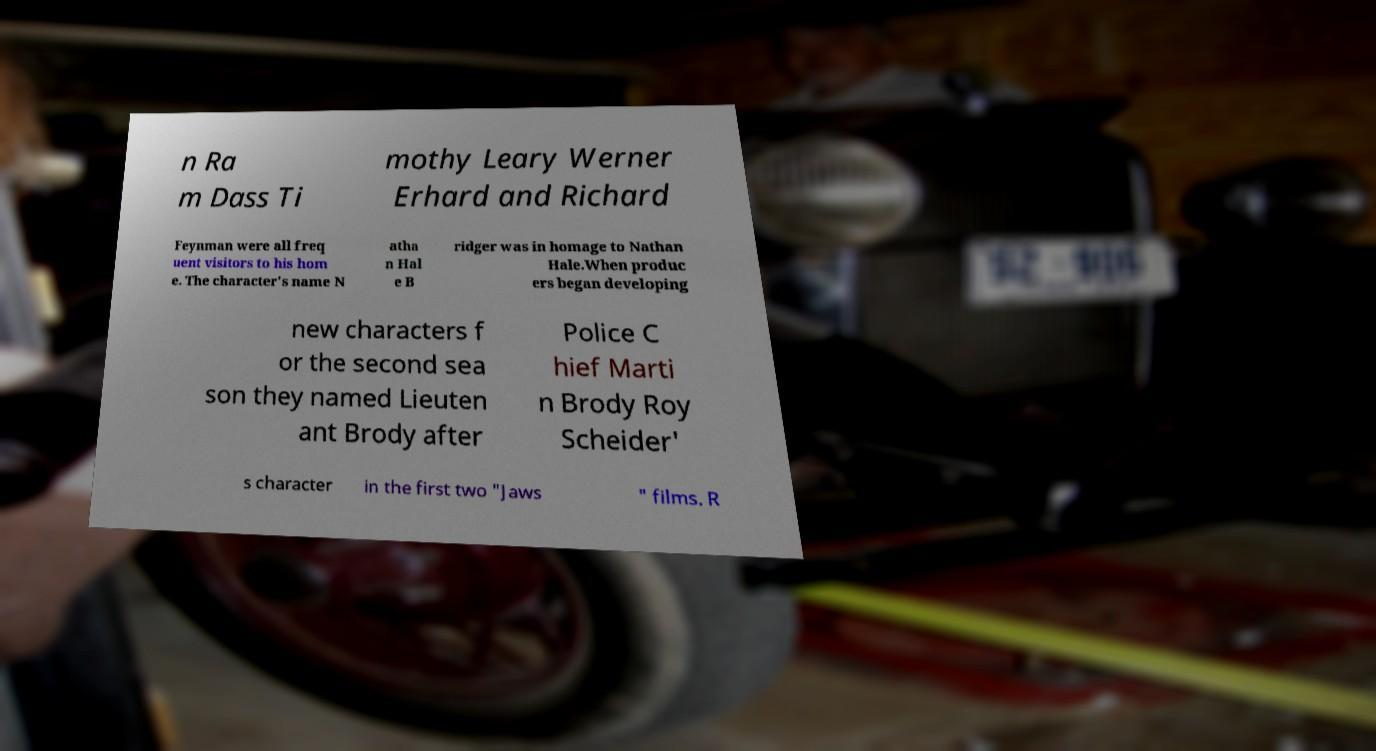For documentation purposes, I need the text within this image transcribed. Could you provide that? n Ra m Dass Ti mothy Leary Werner Erhard and Richard Feynman were all freq uent visitors to his hom e. The character's name N atha n Hal e B ridger was in homage to Nathan Hale.When produc ers began developing new characters f or the second sea son they named Lieuten ant Brody after Police C hief Marti n Brody Roy Scheider' s character in the first two "Jaws " films. R 